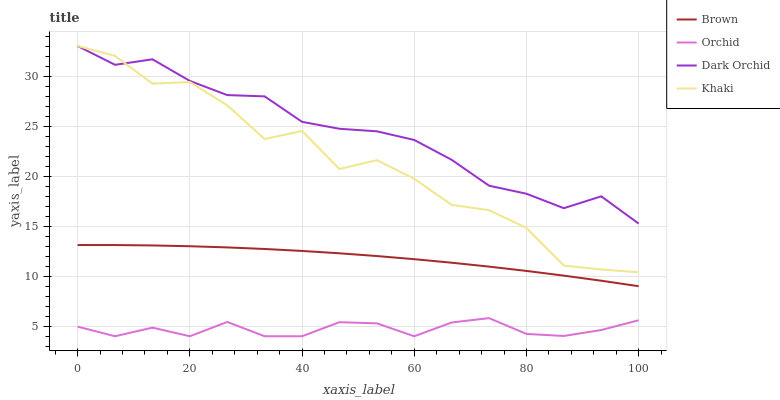Does Orchid have the minimum area under the curve?
Answer yes or no. Yes. Does Dark Orchid have the maximum area under the curve?
Answer yes or no. Yes. Does Khaki have the minimum area under the curve?
Answer yes or no. No. Does Khaki have the maximum area under the curve?
Answer yes or no. No. Is Brown the smoothest?
Answer yes or no. Yes. Is Khaki the roughest?
Answer yes or no. Yes. Is Dark Orchid the smoothest?
Answer yes or no. No. Is Dark Orchid the roughest?
Answer yes or no. No. Does Orchid have the lowest value?
Answer yes or no. Yes. Does Khaki have the lowest value?
Answer yes or no. No. Does Dark Orchid have the highest value?
Answer yes or no. Yes. Does Orchid have the highest value?
Answer yes or no. No. Is Orchid less than Brown?
Answer yes or no. Yes. Is Khaki greater than Brown?
Answer yes or no. Yes. Does Dark Orchid intersect Khaki?
Answer yes or no. Yes. Is Dark Orchid less than Khaki?
Answer yes or no. No. Is Dark Orchid greater than Khaki?
Answer yes or no. No. Does Orchid intersect Brown?
Answer yes or no. No. 